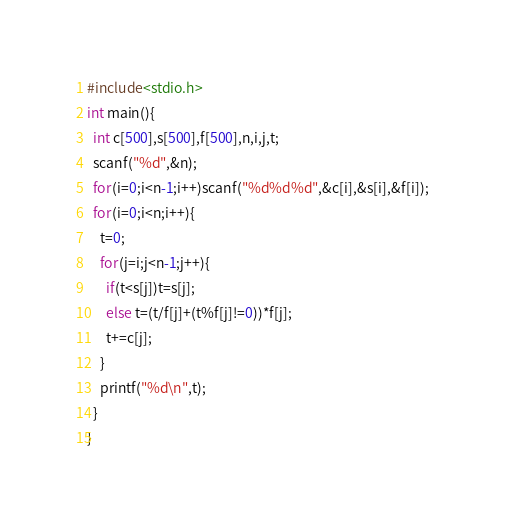Convert code to text. <code><loc_0><loc_0><loc_500><loc_500><_C_>#include<stdio.h>
int main(){
  int c[500],s[500],f[500],n,i,j,t;
  scanf("%d",&n);
  for(i=0;i<n-1;i++)scanf("%d%d%d",&c[i],&s[i],&f[i]);
  for(i=0;i<n;i++){
    t=0;
    for(j=i;j<n-1;j++){
      if(t<s[j])t=s[j];
      else t=(t/f[j]+(t%f[j]!=0))*f[j];
      t+=c[j];
    }
    printf("%d\n",t);
  }
}
</code> 